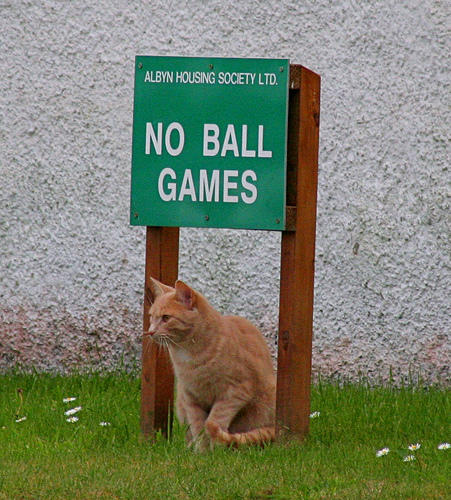Identify the text contained in this image. NO BALL GAMES LTD. SOCIETY HOUSING ALBYN 